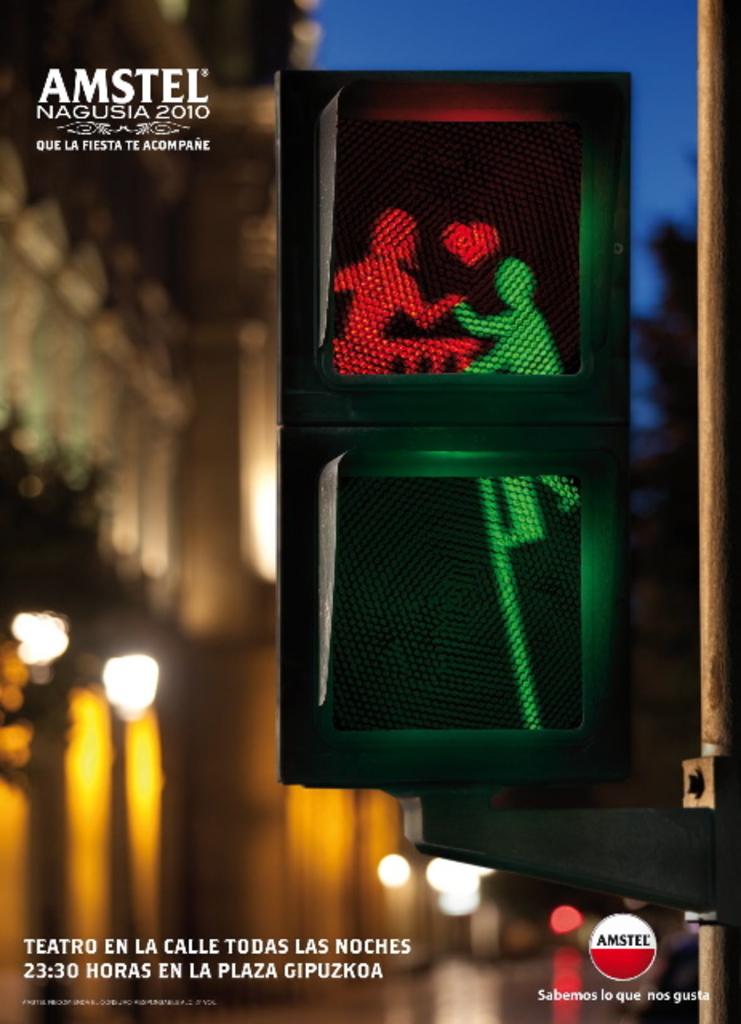What is the name on the board?
Provide a succinct answer. Amstel. What is the year indicated?
Your response must be concise. 2010. 